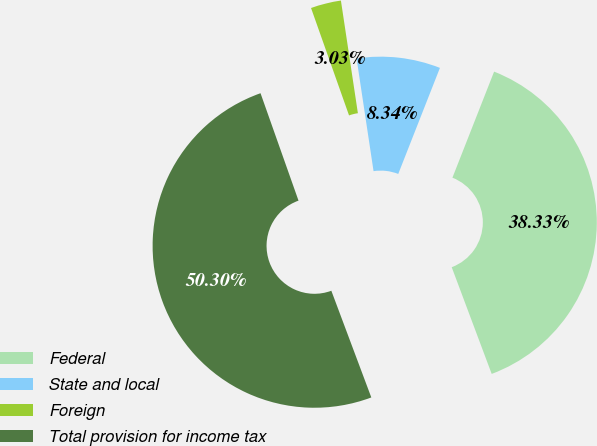<chart> <loc_0><loc_0><loc_500><loc_500><pie_chart><fcel>Federal<fcel>State and local<fcel>Foreign<fcel>Total provision for income tax<nl><fcel>38.33%<fcel>8.34%<fcel>3.03%<fcel>50.29%<nl></chart> 